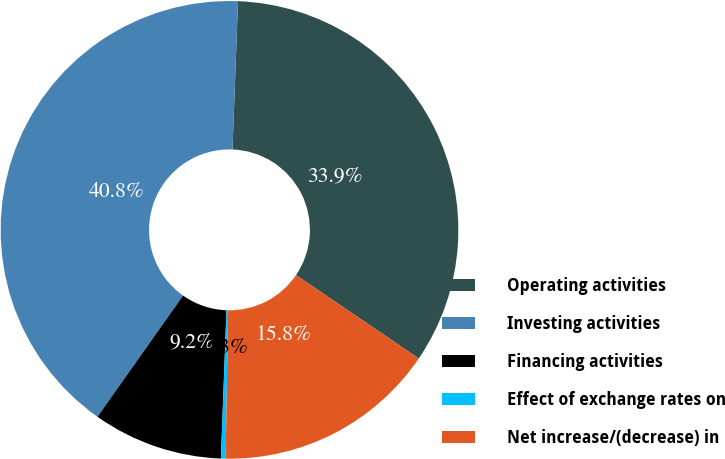<chart> <loc_0><loc_0><loc_500><loc_500><pie_chart><fcel>Operating activities<fcel>Investing activities<fcel>Financing activities<fcel>Effect of exchange rates on<fcel>Net increase/(decrease) in<nl><fcel>33.91%<fcel>40.81%<fcel>9.19%<fcel>0.33%<fcel>15.77%<nl></chart> 